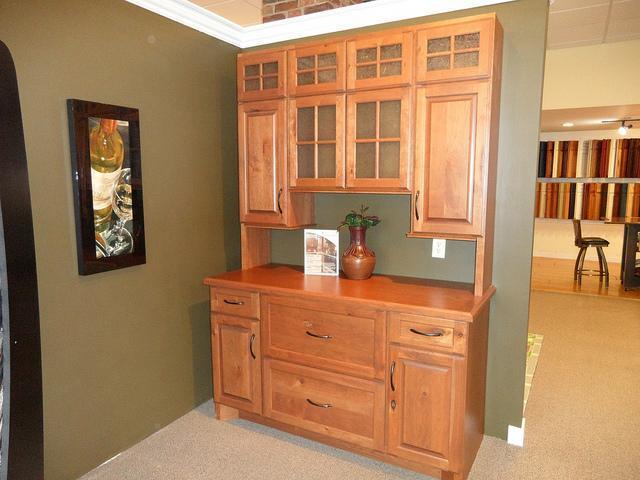How many women are standing there?
Give a very brief answer. 0. How many books are in the photo?
Give a very brief answer. 2. 